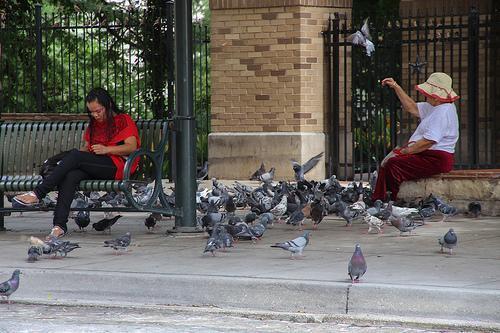How many people do you see in the picture?
Give a very brief answer. 2. 